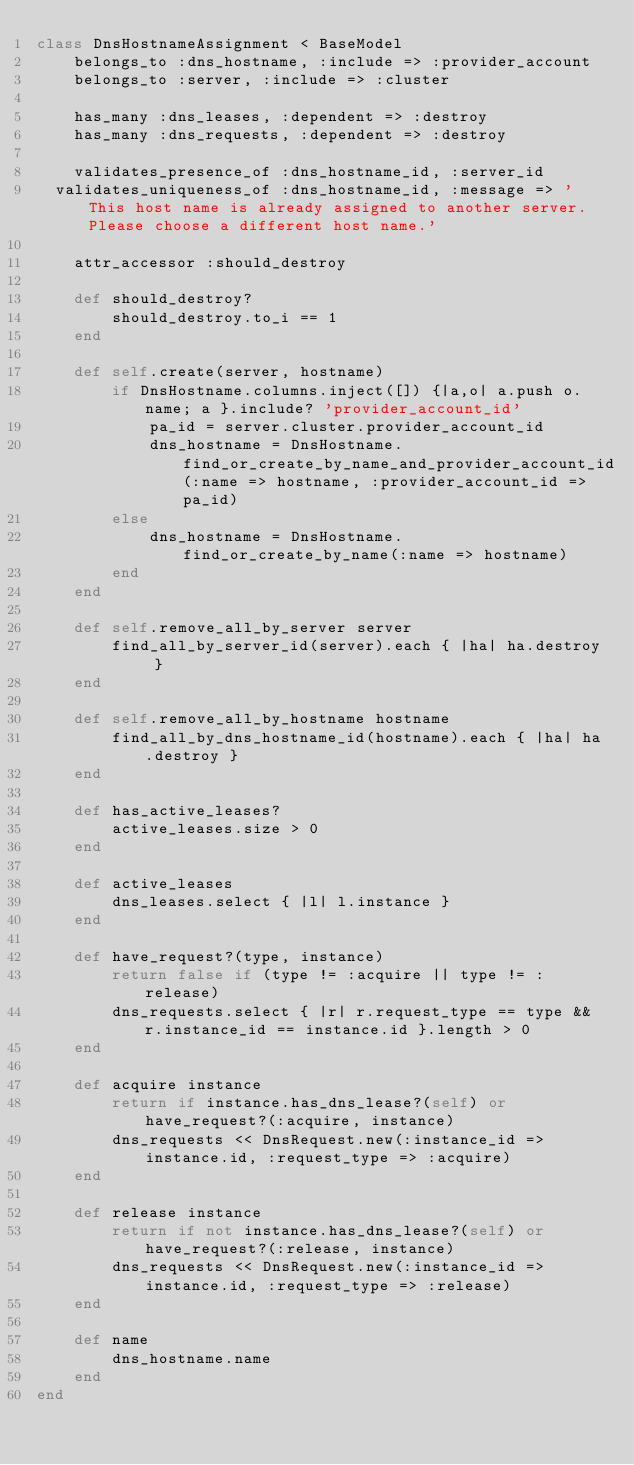<code> <loc_0><loc_0><loc_500><loc_500><_Ruby_>class DnsHostnameAssignment < BaseModel
	belongs_to :dns_hostname, :include => :provider_account
	belongs_to :server, :include => :cluster
	
	has_many :dns_leases, :dependent => :destroy
	has_many :dns_requests, :dependent => :destroy
	
	validates_presence_of :dns_hostname_id, :server_id
  validates_uniqueness_of :dns_hostname_id, :message => 'This host name is already assigned to another server. Please choose a different host name.'

	attr_accessor :should_destroy
	
	def should_destroy?
		should_destroy.to_i == 1
	end
	
	def self.create(server, hostname)
		if DnsHostname.columns.inject([]) {|a,o| a.push o.name; a }.include? 'provider_account_id'
			pa_id = server.cluster.provider_account_id 
			dns_hostname = DnsHostname.find_or_create_by_name_and_provider_account_id(:name => hostname, :provider_account_id => pa_id)
		else
			dns_hostname = DnsHostname.find_or_create_by_name(:name => hostname)
		end
	end
	
	def self.remove_all_by_server server
		find_all_by_server_id(server).each { |ha| ha.destroy }
	end
	
	def self.remove_all_by_hostname hostname
		find_all_by_dns_hostname_id(hostname).each { |ha| ha.destroy }
	end

	def has_active_leases?
		active_leases.size > 0
	end
	
	def active_leases
		dns_leases.select { |l| l.instance } 
	end
	
	def have_request?(type, instance)
		return false if (type != :acquire || type != :release)
		dns_requests.select { |r| r.request_type == type && r.instance_id == instance.id }.length > 0
	end
	
	def acquire instance
		return if instance.has_dns_lease?(self) or have_request?(:acquire, instance) 
		dns_requests << DnsRequest.new(:instance_id => instance.id, :request_type => :acquire)
	end
	
	def release instance
		return if not instance.has_dns_lease?(self) or have_request?(:release, instance)
		dns_requests << DnsRequest.new(:instance_id => instance.id, :request_type => :release)
	end

	def name
		dns_hostname.name
	end
end
</code> 